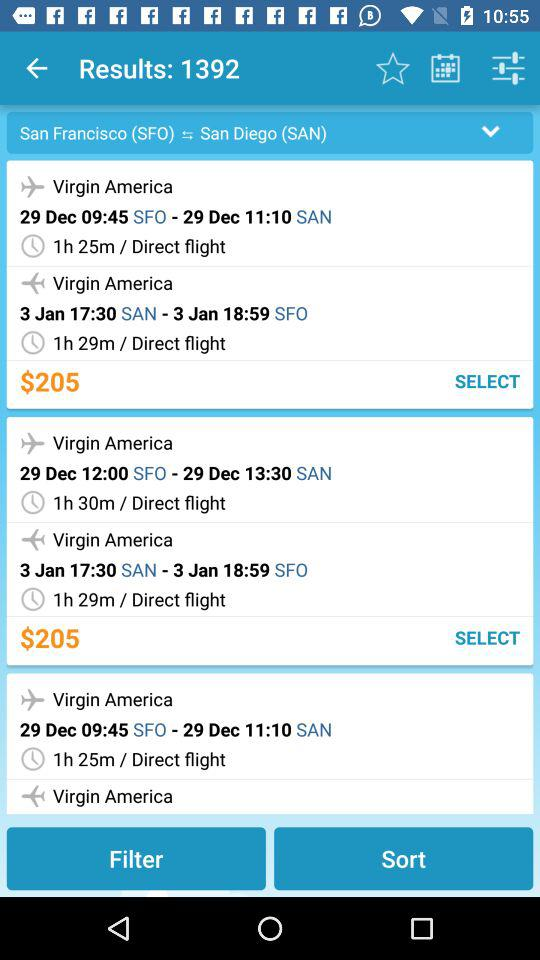What is the departure time of the flight from SFO to SAN, which has a duration of 1 hour 25 minutes? The departure time is 09:45. 